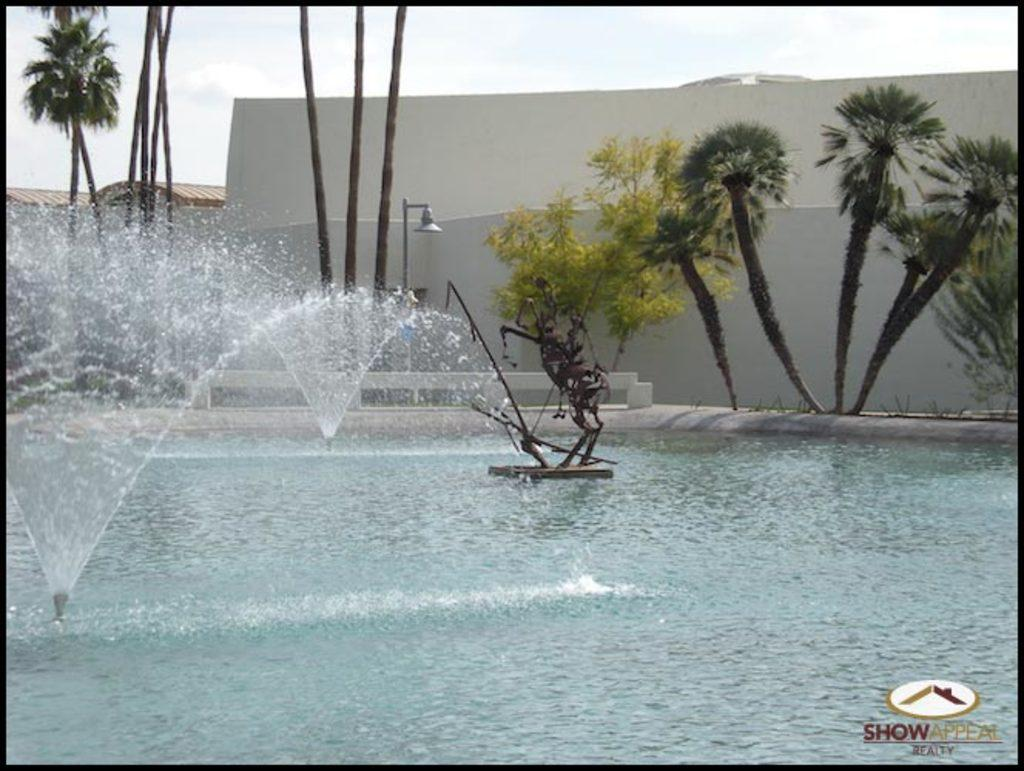What is the main subject in the image? There is a statue in the image. What is happening with the water in the image? There are fountains on the water in the image. What can be seen in the background of the image? There are many trees, a light pole, a wall, and the sky visible in the background of the image. How many pieces of pie are on the statue in the image? There is no pie present in the image; it features a statue and fountains on the water. Can you see any cobwebs on the statue in the image? There is no mention of cobwebs in the image, and they are not visible in the provided facts. 